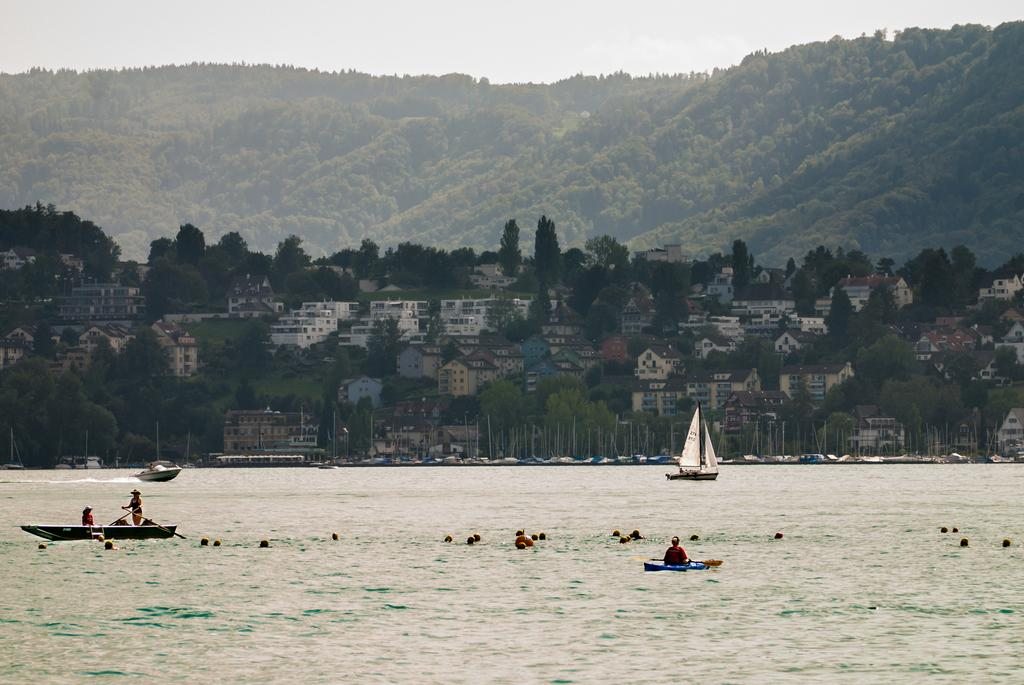What type of vehicles can be seen in the river water? There are boats in the river water. Can you describe the boat in the background? There is a sailing boat in the background. What can be seen in the background besides the sailing boat? There are buildings, trees, and a huge mountain full of trees in the background. How does the person in the image say good-bye to the boats? There is no person present in the image, so it is not possible to determine how they would say good-bye to the boats. 